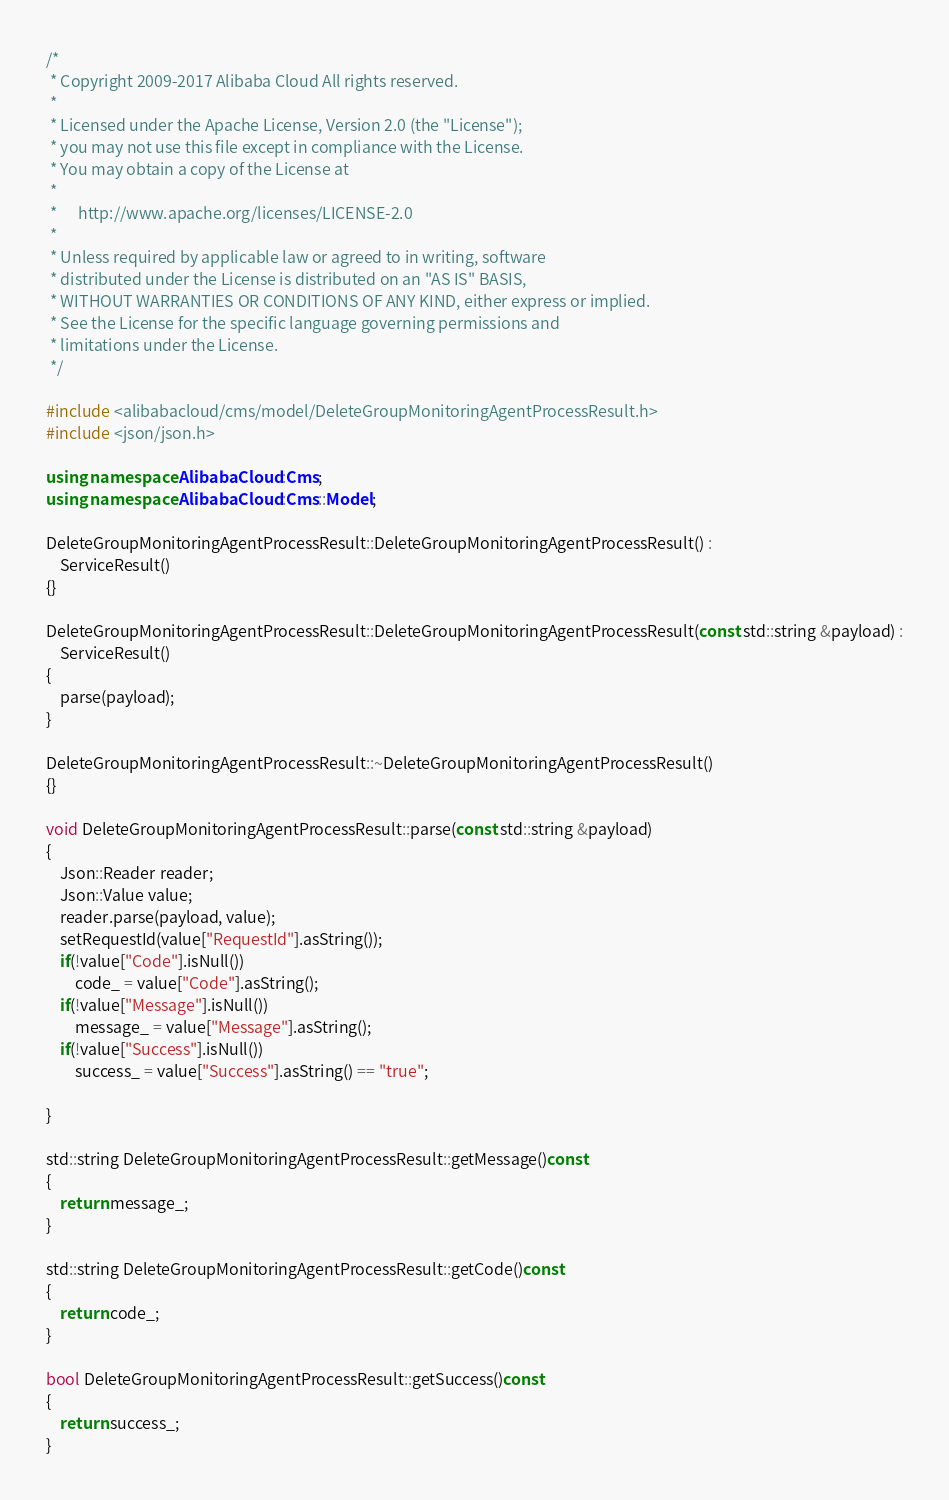<code> <loc_0><loc_0><loc_500><loc_500><_C++_>/*
 * Copyright 2009-2017 Alibaba Cloud All rights reserved.
 * 
 * Licensed under the Apache License, Version 2.0 (the "License");
 * you may not use this file except in compliance with the License.
 * You may obtain a copy of the License at
 * 
 *      http://www.apache.org/licenses/LICENSE-2.0
 * 
 * Unless required by applicable law or agreed to in writing, software
 * distributed under the License is distributed on an "AS IS" BASIS,
 * WITHOUT WARRANTIES OR CONDITIONS OF ANY KIND, either express or implied.
 * See the License for the specific language governing permissions and
 * limitations under the License.
 */

#include <alibabacloud/cms/model/DeleteGroupMonitoringAgentProcessResult.h>
#include <json/json.h>

using namespace AlibabaCloud::Cms;
using namespace AlibabaCloud::Cms::Model;

DeleteGroupMonitoringAgentProcessResult::DeleteGroupMonitoringAgentProcessResult() :
	ServiceResult()
{}

DeleteGroupMonitoringAgentProcessResult::DeleteGroupMonitoringAgentProcessResult(const std::string &payload) :
	ServiceResult()
{
	parse(payload);
}

DeleteGroupMonitoringAgentProcessResult::~DeleteGroupMonitoringAgentProcessResult()
{}

void DeleteGroupMonitoringAgentProcessResult::parse(const std::string &payload)
{
	Json::Reader reader;
	Json::Value value;
	reader.parse(payload, value);
	setRequestId(value["RequestId"].asString());
	if(!value["Code"].isNull())
		code_ = value["Code"].asString();
	if(!value["Message"].isNull())
		message_ = value["Message"].asString();
	if(!value["Success"].isNull())
		success_ = value["Success"].asString() == "true";

}

std::string DeleteGroupMonitoringAgentProcessResult::getMessage()const
{
	return message_;
}

std::string DeleteGroupMonitoringAgentProcessResult::getCode()const
{
	return code_;
}

bool DeleteGroupMonitoringAgentProcessResult::getSuccess()const
{
	return success_;
}

</code> 